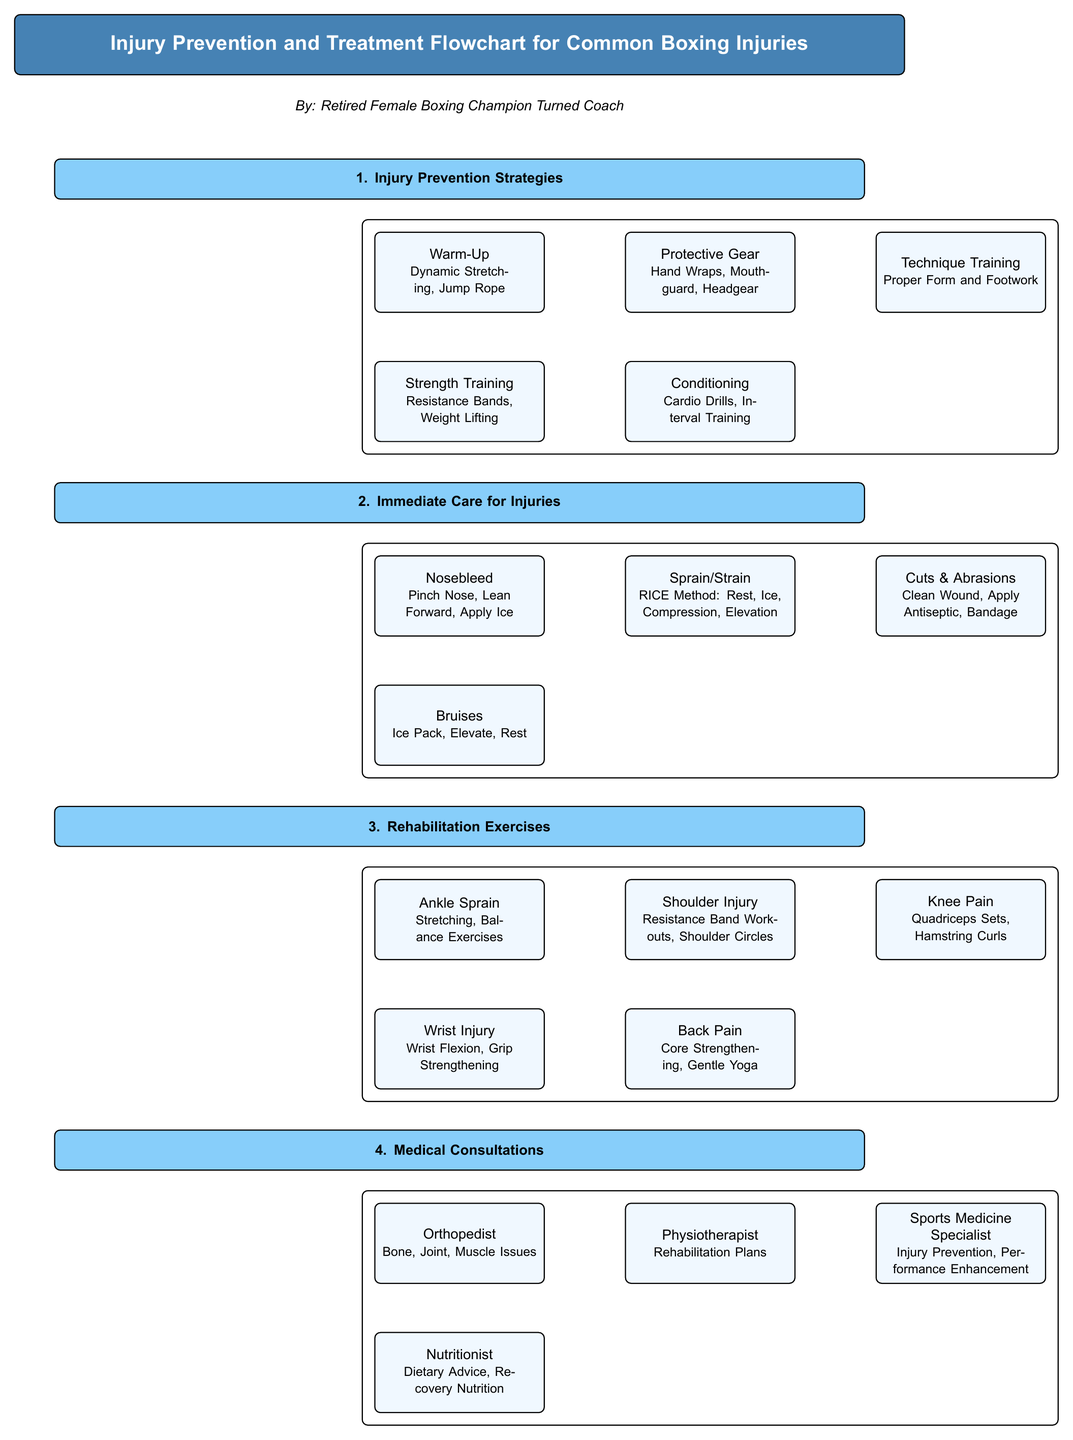What is the title of the diagram? The title node is the first node in the diagram and reads "Injury Prevention and Treatment Flowchart for Common Boxing Injuries."
Answer: Injury Prevention and Treatment Flowchart for Common Boxing Injuries How many sections are in the diagram? There are four main sections identified in the diagram: Injury Prevention Strategies, Immediate Care for Injuries, Rehabilitation Exercises, and Medical Consultations.
Answer: 4 What is the immediate care method for a sprain/strain? The box for sprain/strain lists "RICE Method: Rest, Ice, Compression, Elevation" as the immediate care method.
Answer: RICE Method: Rest, Ice, Compression, Elevation Which medical specialist is recommended for nutrition advice? According to the Medical Consultations section, the Nutritionist is the specialist listed for dietary advice and recovery nutrition.
Answer: Nutritionist What rehabilitation exercise is suggested for shoulder injuries? The box under Rehabilitation Exercises for shoulder injuries mentions "Resistance Band Workouts, Shoulder Circles."
Answer: Resistance Band Workouts, Shoulder Circles What are the two strategies listed under Injury Prevention for conditioning? The Conditioning box provides "Cardio Drills, Interval Training" as strategies for improving conditioning, which are the focus of that node.
Answer: Cardio Drills, Interval Training Which section contains the node for bruises? The node for bruises is located in the "Immediate Care for Injuries" section, listed below the nosebleed node.
Answer: Immediate Care for Injuries What type of injuries does a Sports Medicine Specialist address? The Sports Medicine Specialist is listed in the Medical Consultations section for "Injury Prevention, Performance Enhancement."
Answer: Injury Prevention, Performance Enhancement What type of training is recommended for prevention strategies focusing on strength? The box below the Warm-Up node specifies "Strength Training" that includes "Resistance Bands, Weight Lifting."
Answer: Strength Training 